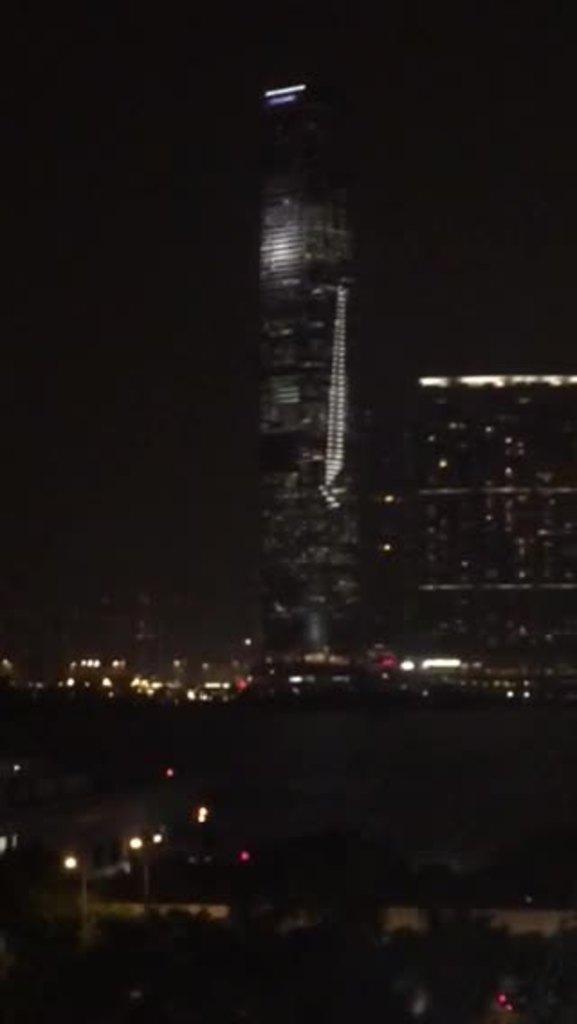In one or two sentences, can you explain what this image depicts? It is an image in the night time, in this there are very big buildings with the lights at the top it is the sky. 